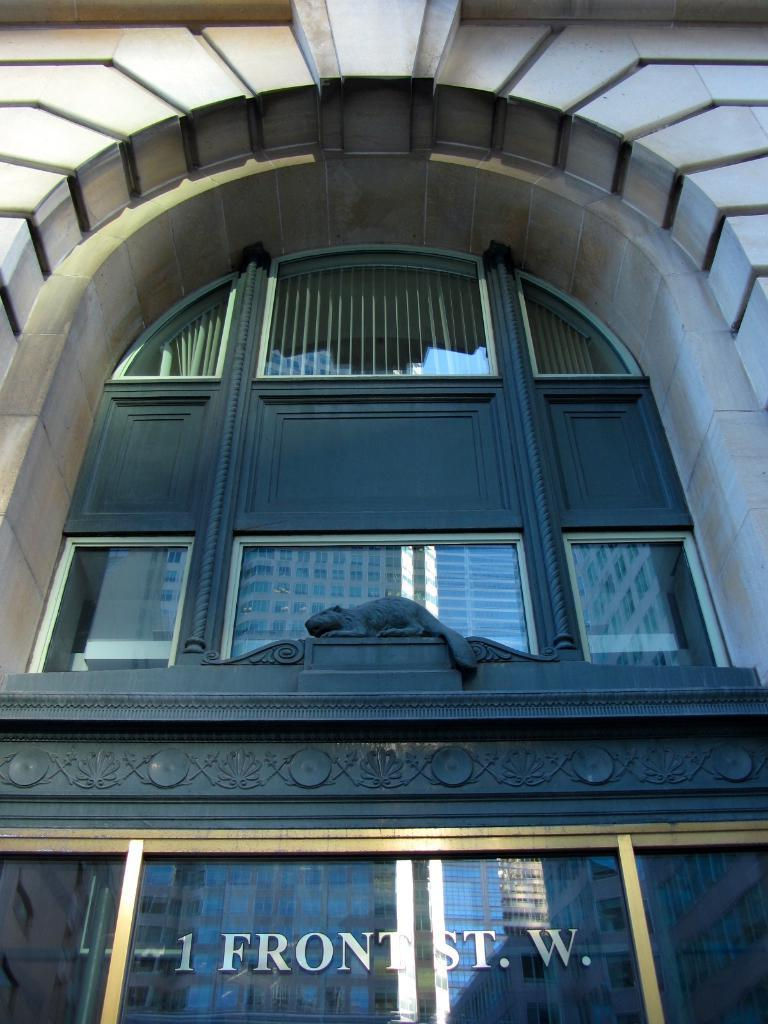What type of structure is visible in the image? There is a building in the image. What other object can be seen near the building? There is a statue in the image. What feature is present on the building? There are windows in the image. What is written or displayed on the glass at the bottom of the image? There is text on glass at the bottom of the image. What type of insect can be seen crawling on the statue in the image? There is no insect present on the statue in the image. What type of food is being served in the building in the image? The image does not show any food being served or prepared in the building. 